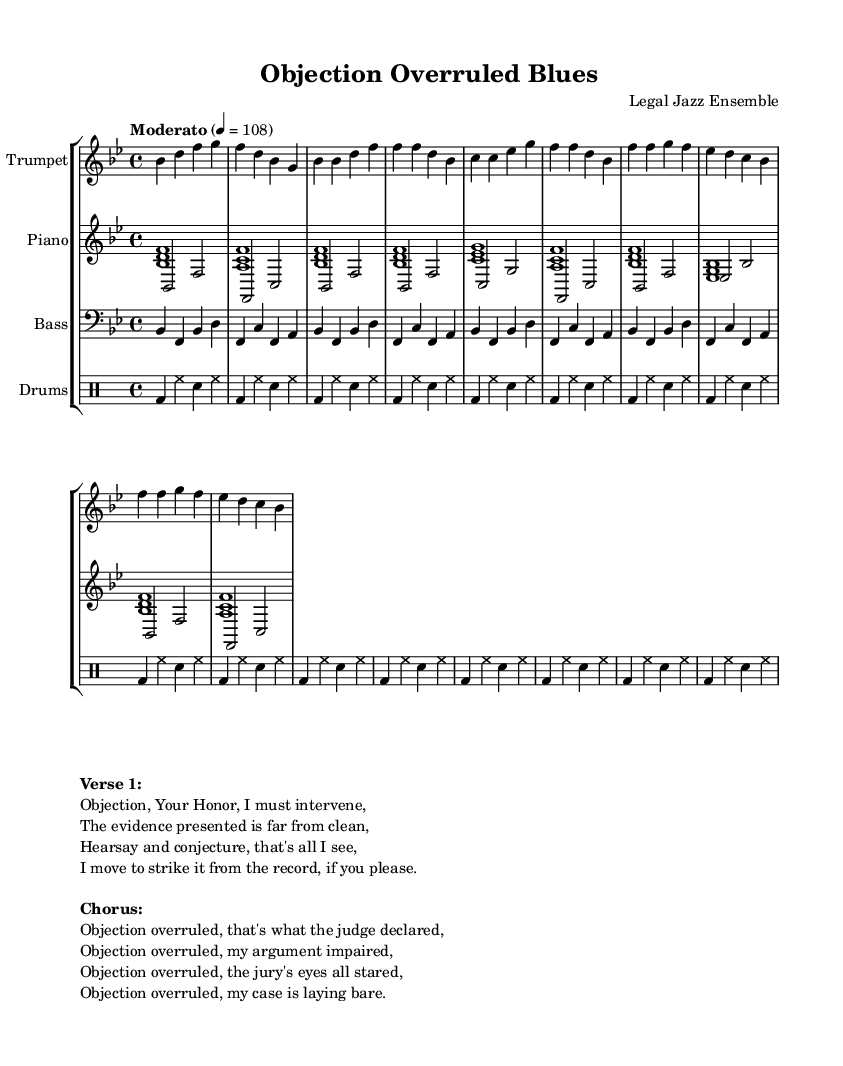What is the key signature of this music? The key signature is indicated at the beginning of the score, which shows two flats. This corresponds to B flat major.
Answer: B flat major What is the time signature of this piece? The time signature appears right after the key signature at the beginning of the score, showing 4 over 4, meaning there are four beats in a measure and the quarter note gets one beat.
Answer: 4/4 What is the tempo marking for this score? The tempo marking is written above the score, stating "Moderato" with a tempo indication of quarter note equals 108 beats per minute, suggesting a moderate speed for the performance.
Answer: Moderato How many measures are in the verse section? To determine the number of measures in the verse section, one can count the measures specifically designated for the verse within the score. The verse contains four measures as indicated explicitly beneath the lyrics.
Answer: 4 What is the main theme of the chorus lyrics? The chorus lyrics focus on the phrase "Objection overruled," emphasizing a legal objection that the judge has declared invalid, which indicates the frustration and challenges faced by the protagonist in the courtroom setting.
Answer: Objection overruled How many different instruments are used in this piece? The score shows distinct staves for the trumpet, piano, bass, and drums. Each instrument has its own dedicated staff, meaning there are four different instruments depicted.
Answer: 4 